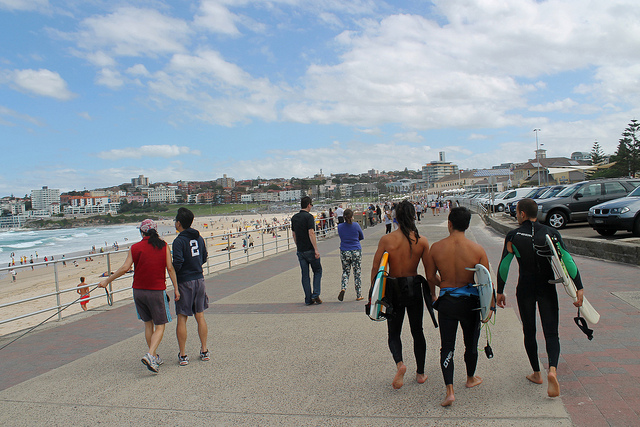Please extract the text content from this image. 2 